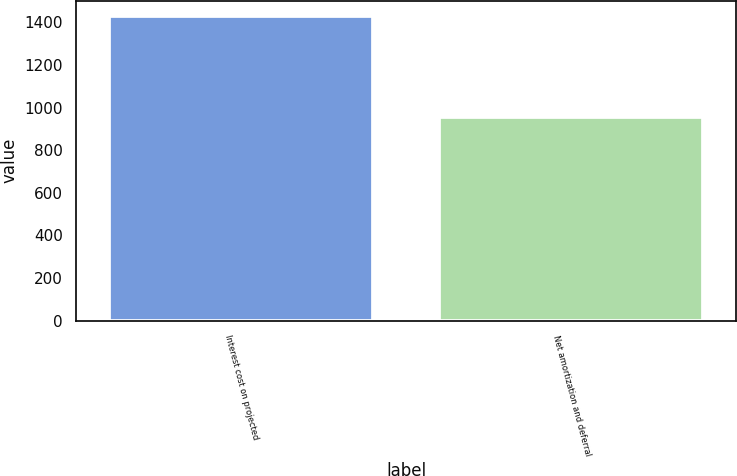<chart> <loc_0><loc_0><loc_500><loc_500><bar_chart><fcel>Interest cost on projected<fcel>Net amortization and deferral<nl><fcel>1431<fcel>958<nl></chart> 